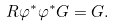<formula> <loc_0><loc_0><loc_500><loc_500>R \varphi ^ { \ast } \varphi ^ { \ast } G = G .</formula> 